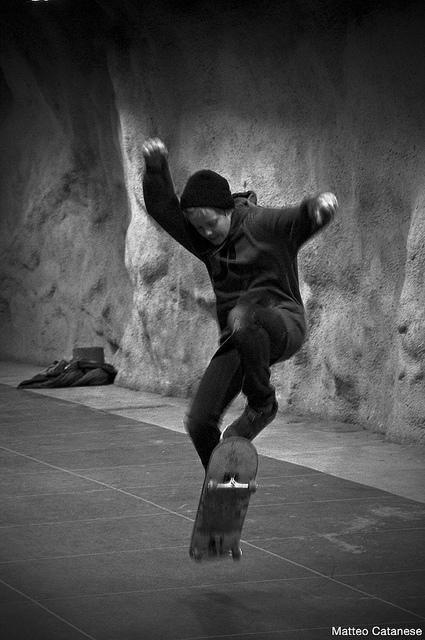Is this kid flying?
Short answer required. No. Where this guy is playing with board?
Write a very short answer. Street. Is the boy wearing a hat?
Quick response, please. Yes. 